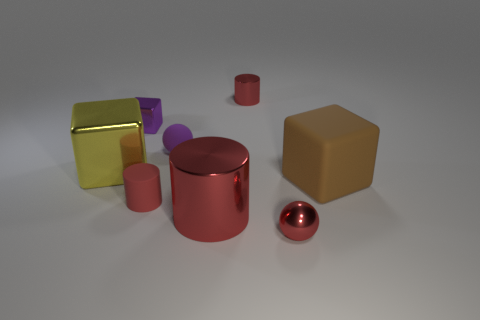The tiny red thing that is in front of the tiny metal cube and on the right side of the tiny purple rubber thing is made of what material?
Your response must be concise. Metal. Are the yellow cube and the large brown cube made of the same material?
Your answer should be very brief. No. There is a matte thing that is both in front of the tiny matte ball and left of the big matte thing; what is its shape?
Make the answer very short. Cylinder. Is the large metal cube the same color as the big rubber block?
Provide a succinct answer. No. How many tiny gray cylinders are made of the same material as the large cylinder?
Your answer should be very brief. 0. There is a small red metallic thing left of the tiny red metallic sphere; what is its shape?
Your response must be concise. Cylinder. Is the material of the brown cube the same as the red cylinder behind the purple rubber object?
Offer a very short reply. No. Are there any big yellow rubber balls?
Offer a terse response. No. There is a red shiny thing behind the metallic cylinder in front of the rubber ball; are there any yellow shiny things that are to the right of it?
Offer a very short reply. No. How many large things are purple metal cubes or yellow things?
Offer a terse response. 1. 